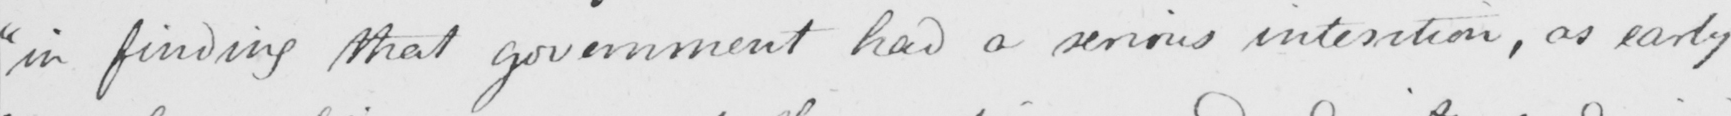Transcribe the text shown in this historical manuscript line. " in finding that government had a serious intention , as early 